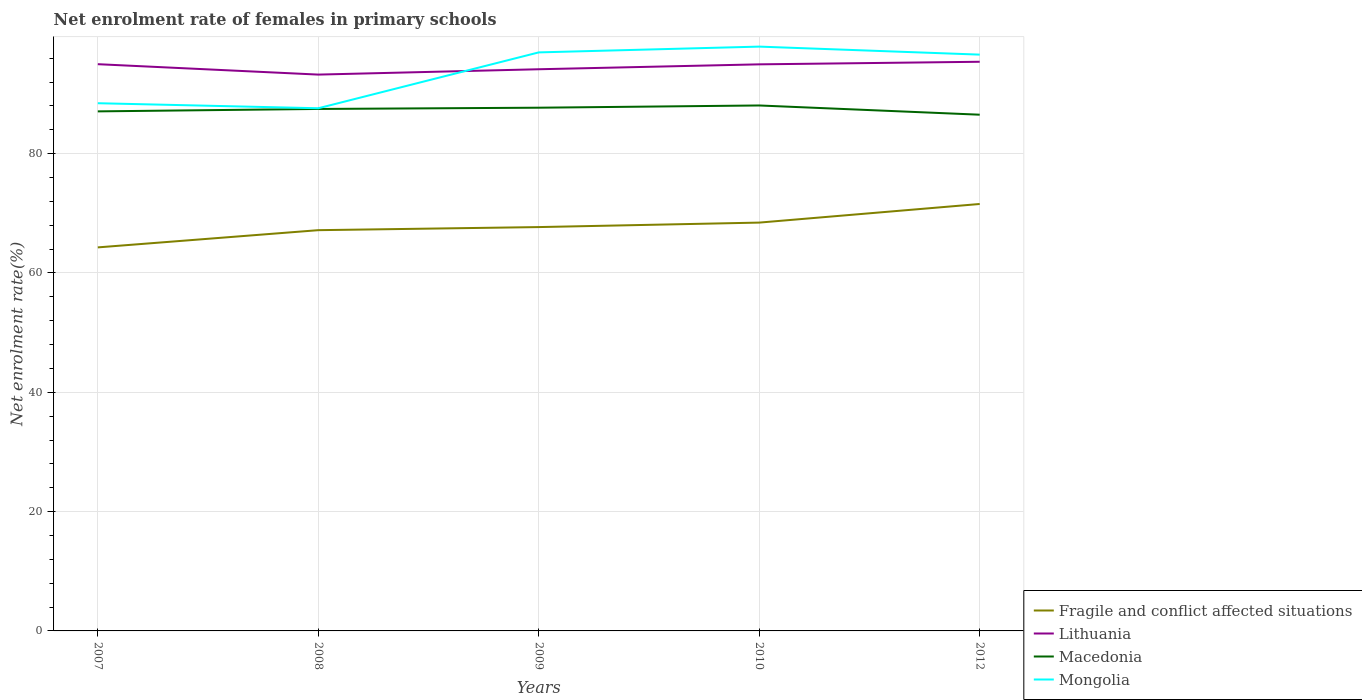How many different coloured lines are there?
Provide a succinct answer. 4. Does the line corresponding to Macedonia intersect with the line corresponding to Fragile and conflict affected situations?
Give a very brief answer. No. Across all years, what is the maximum net enrolment rate of females in primary schools in Fragile and conflict affected situations?
Make the answer very short. 64.29. In which year was the net enrolment rate of females in primary schools in Macedonia maximum?
Your answer should be very brief. 2012. What is the total net enrolment rate of females in primary schools in Macedonia in the graph?
Provide a short and direct response. -0.58. What is the difference between the highest and the second highest net enrolment rate of females in primary schools in Lithuania?
Provide a short and direct response. 2.15. How many lines are there?
Provide a succinct answer. 4. Does the graph contain any zero values?
Your answer should be compact. No. Does the graph contain grids?
Your response must be concise. Yes. How many legend labels are there?
Offer a very short reply. 4. What is the title of the graph?
Provide a short and direct response. Net enrolment rate of females in primary schools. What is the label or title of the X-axis?
Provide a succinct answer. Years. What is the label or title of the Y-axis?
Provide a short and direct response. Net enrolment rate(%). What is the Net enrolment rate(%) of Fragile and conflict affected situations in 2007?
Make the answer very short. 64.29. What is the Net enrolment rate(%) in Lithuania in 2007?
Make the answer very short. 95. What is the Net enrolment rate(%) in Macedonia in 2007?
Provide a succinct answer. 87.09. What is the Net enrolment rate(%) of Mongolia in 2007?
Provide a short and direct response. 88.46. What is the Net enrolment rate(%) in Fragile and conflict affected situations in 2008?
Your response must be concise. 67.17. What is the Net enrolment rate(%) in Lithuania in 2008?
Your answer should be very brief. 93.25. What is the Net enrolment rate(%) in Macedonia in 2008?
Your response must be concise. 87.5. What is the Net enrolment rate(%) of Mongolia in 2008?
Keep it short and to the point. 87.61. What is the Net enrolment rate(%) in Fragile and conflict affected situations in 2009?
Give a very brief answer. 67.69. What is the Net enrolment rate(%) of Lithuania in 2009?
Keep it short and to the point. 94.15. What is the Net enrolment rate(%) in Macedonia in 2009?
Offer a terse response. 87.7. What is the Net enrolment rate(%) in Mongolia in 2009?
Provide a short and direct response. 96.97. What is the Net enrolment rate(%) of Fragile and conflict affected situations in 2010?
Your answer should be compact. 68.44. What is the Net enrolment rate(%) in Lithuania in 2010?
Offer a terse response. 94.97. What is the Net enrolment rate(%) in Macedonia in 2010?
Your response must be concise. 88.08. What is the Net enrolment rate(%) in Mongolia in 2010?
Provide a succinct answer. 97.94. What is the Net enrolment rate(%) of Fragile and conflict affected situations in 2012?
Your response must be concise. 71.57. What is the Net enrolment rate(%) in Lithuania in 2012?
Your answer should be very brief. 95.41. What is the Net enrolment rate(%) of Macedonia in 2012?
Your answer should be very brief. 86.53. What is the Net enrolment rate(%) of Mongolia in 2012?
Keep it short and to the point. 96.6. Across all years, what is the maximum Net enrolment rate(%) in Fragile and conflict affected situations?
Your answer should be compact. 71.57. Across all years, what is the maximum Net enrolment rate(%) of Lithuania?
Provide a succinct answer. 95.41. Across all years, what is the maximum Net enrolment rate(%) of Macedonia?
Provide a succinct answer. 88.08. Across all years, what is the maximum Net enrolment rate(%) of Mongolia?
Your answer should be very brief. 97.94. Across all years, what is the minimum Net enrolment rate(%) of Fragile and conflict affected situations?
Keep it short and to the point. 64.29. Across all years, what is the minimum Net enrolment rate(%) in Lithuania?
Ensure brevity in your answer.  93.25. Across all years, what is the minimum Net enrolment rate(%) in Macedonia?
Make the answer very short. 86.53. Across all years, what is the minimum Net enrolment rate(%) in Mongolia?
Make the answer very short. 87.61. What is the total Net enrolment rate(%) in Fragile and conflict affected situations in the graph?
Keep it short and to the point. 339.17. What is the total Net enrolment rate(%) in Lithuania in the graph?
Ensure brevity in your answer.  472.78. What is the total Net enrolment rate(%) in Macedonia in the graph?
Your response must be concise. 436.89. What is the total Net enrolment rate(%) of Mongolia in the graph?
Offer a terse response. 467.59. What is the difference between the Net enrolment rate(%) of Fragile and conflict affected situations in 2007 and that in 2008?
Give a very brief answer. -2.89. What is the difference between the Net enrolment rate(%) of Lithuania in 2007 and that in 2008?
Offer a very short reply. 1.74. What is the difference between the Net enrolment rate(%) in Macedonia in 2007 and that in 2008?
Ensure brevity in your answer.  -0.41. What is the difference between the Net enrolment rate(%) of Mongolia in 2007 and that in 2008?
Provide a succinct answer. 0.84. What is the difference between the Net enrolment rate(%) of Fragile and conflict affected situations in 2007 and that in 2009?
Provide a short and direct response. -3.41. What is the difference between the Net enrolment rate(%) in Lithuania in 2007 and that in 2009?
Make the answer very short. 0.85. What is the difference between the Net enrolment rate(%) in Macedonia in 2007 and that in 2009?
Give a very brief answer. -0.62. What is the difference between the Net enrolment rate(%) of Mongolia in 2007 and that in 2009?
Offer a very short reply. -8.52. What is the difference between the Net enrolment rate(%) of Fragile and conflict affected situations in 2007 and that in 2010?
Provide a succinct answer. -4.16. What is the difference between the Net enrolment rate(%) in Lithuania in 2007 and that in 2010?
Provide a short and direct response. 0.03. What is the difference between the Net enrolment rate(%) in Macedonia in 2007 and that in 2010?
Give a very brief answer. -0.99. What is the difference between the Net enrolment rate(%) of Mongolia in 2007 and that in 2010?
Your answer should be very brief. -9.49. What is the difference between the Net enrolment rate(%) of Fragile and conflict affected situations in 2007 and that in 2012?
Your answer should be very brief. -7.28. What is the difference between the Net enrolment rate(%) of Lithuania in 2007 and that in 2012?
Your answer should be compact. -0.41. What is the difference between the Net enrolment rate(%) of Macedonia in 2007 and that in 2012?
Keep it short and to the point. 0.56. What is the difference between the Net enrolment rate(%) in Mongolia in 2007 and that in 2012?
Offer a terse response. -8.15. What is the difference between the Net enrolment rate(%) in Fragile and conflict affected situations in 2008 and that in 2009?
Give a very brief answer. -0.52. What is the difference between the Net enrolment rate(%) in Lithuania in 2008 and that in 2009?
Provide a short and direct response. -0.9. What is the difference between the Net enrolment rate(%) of Macedonia in 2008 and that in 2009?
Offer a very short reply. -0.21. What is the difference between the Net enrolment rate(%) in Mongolia in 2008 and that in 2009?
Offer a very short reply. -9.36. What is the difference between the Net enrolment rate(%) of Fragile and conflict affected situations in 2008 and that in 2010?
Offer a very short reply. -1.27. What is the difference between the Net enrolment rate(%) in Lithuania in 2008 and that in 2010?
Provide a short and direct response. -1.72. What is the difference between the Net enrolment rate(%) of Macedonia in 2008 and that in 2010?
Your answer should be very brief. -0.58. What is the difference between the Net enrolment rate(%) of Mongolia in 2008 and that in 2010?
Keep it short and to the point. -10.33. What is the difference between the Net enrolment rate(%) in Fragile and conflict affected situations in 2008 and that in 2012?
Provide a short and direct response. -4.39. What is the difference between the Net enrolment rate(%) in Lithuania in 2008 and that in 2012?
Your answer should be very brief. -2.15. What is the difference between the Net enrolment rate(%) of Macedonia in 2008 and that in 2012?
Provide a short and direct response. 0.97. What is the difference between the Net enrolment rate(%) in Mongolia in 2008 and that in 2012?
Your answer should be compact. -8.99. What is the difference between the Net enrolment rate(%) of Fragile and conflict affected situations in 2009 and that in 2010?
Your answer should be compact. -0.75. What is the difference between the Net enrolment rate(%) in Lithuania in 2009 and that in 2010?
Offer a very short reply. -0.82. What is the difference between the Net enrolment rate(%) of Macedonia in 2009 and that in 2010?
Your answer should be very brief. -0.38. What is the difference between the Net enrolment rate(%) of Mongolia in 2009 and that in 2010?
Ensure brevity in your answer.  -0.97. What is the difference between the Net enrolment rate(%) of Fragile and conflict affected situations in 2009 and that in 2012?
Provide a succinct answer. -3.87. What is the difference between the Net enrolment rate(%) in Lithuania in 2009 and that in 2012?
Your response must be concise. -1.26. What is the difference between the Net enrolment rate(%) in Macedonia in 2009 and that in 2012?
Provide a succinct answer. 1.17. What is the difference between the Net enrolment rate(%) in Mongolia in 2009 and that in 2012?
Keep it short and to the point. 0.37. What is the difference between the Net enrolment rate(%) in Fragile and conflict affected situations in 2010 and that in 2012?
Make the answer very short. -3.12. What is the difference between the Net enrolment rate(%) of Lithuania in 2010 and that in 2012?
Give a very brief answer. -0.43. What is the difference between the Net enrolment rate(%) in Macedonia in 2010 and that in 2012?
Your response must be concise. 1.55. What is the difference between the Net enrolment rate(%) of Mongolia in 2010 and that in 2012?
Provide a short and direct response. 1.34. What is the difference between the Net enrolment rate(%) in Fragile and conflict affected situations in 2007 and the Net enrolment rate(%) in Lithuania in 2008?
Make the answer very short. -28.97. What is the difference between the Net enrolment rate(%) of Fragile and conflict affected situations in 2007 and the Net enrolment rate(%) of Macedonia in 2008?
Keep it short and to the point. -23.21. What is the difference between the Net enrolment rate(%) of Fragile and conflict affected situations in 2007 and the Net enrolment rate(%) of Mongolia in 2008?
Offer a terse response. -23.32. What is the difference between the Net enrolment rate(%) of Lithuania in 2007 and the Net enrolment rate(%) of Macedonia in 2008?
Your response must be concise. 7.5. What is the difference between the Net enrolment rate(%) of Lithuania in 2007 and the Net enrolment rate(%) of Mongolia in 2008?
Give a very brief answer. 7.39. What is the difference between the Net enrolment rate(%) in Macedonia in 2007 and the Net enrolment rate(%) in Mongolia in 2008?
Provide a short and direct response. -0.52. What is the difference between the Net enrolment rate(%) in Fragile and conflict affected situations in 2007 and the Net enrolment rate(%) in Lithuania in 2009?
Make the answer very short. -29.86. What is the difference between the Net enrolment rate(%) in Fragile and conflict affected situations in 2007 and the Net enrolment rate(%) in Macedonia in 2009?
Offer a very short reply. -23.41. What is the difference between the Net enrolment rate(%) of Fragile and conflict affected situations in 2007 and the Net enrolment rate(%) of Mongolia in 2009?
Provide a short and direct response. -32.69. What is the difference between the Net enrolment rate(%) in Lithuania in 2007 and the Net enrolment rate(%) in Macedonia in 2009?
Provide a short and direct response. 7.3. What is the difference between the Net enrolment rate(%) in Lithuania in 2007 and the Net enrolment rate(%) in Mongolia in 2009?
Your answer should be compact. -1.98. What is the difference between the Net enrolment rate(%) of Macedonia in 2007 and the Net enrolment rate(%) of Mongolia in 2009?
Your response must be concise. -9.89. What is the difference between the Net enrolment rate(%) of Fragile and conflict affected situations in 2007 and the Net enrolment rate(%) of Lithuania in 2010?
Your response must be concise. -30.68. What is the difference between the Net enrolment rate(%) of Fragile and conflict affected situations in 2007 and the Net enrolment rate(%) of Macedonia in 2010?
Offer a terse response. -23.79. What is the difference between the Net enrolment rate(%) of Fragile and conflict affected situations in 2007 and the Net enrolment rate(%) of Mongolia in 2010?
Offer a very short reply. -33.66. What is the difference between the Net enrolment rate(%) in Lithuania in 2007 and the Net enrolment rate(%) in Macedonia in 2010?
Provide a short and direct response. 6.92. What is the difference between the Net enrolment rate(%) in Lithuania in 2007 and the Net enrolment rate(%) in Mongolia in 2010?
Your answer should be very brief. -2.94. What is the difference between the Net enrolment rate(%) in Macedonia in 2007 and the Net enrolment rate(%) in Mongolia in 2010?
Offer a terse response. -10.86. What is the difference between the Net enrolment rate(%) in Fragile and conflict affected situations in 2007 and the Net enrolment rate(%) in Lithuania in 2012?
Offer a terse response. -31.12. What is the difference between the Net enrolment rate(%) in Fragile and conflict affected situations in 2007 and the Net enrolment rate(%) in Macedonia in 2012?
Provide a short and direct response. -22.24. What is the difference between the Net enrolment rate(%) of Fragile and conflict affected situations in 2007 and the Net enrolment rate(%) of Mongolia in 2012?
Offer a terse response. -32.31. What is the difference between the Net enrolment rate(%) of Lithuania in 2007 and the Net enrolment rate(%) of Macedonia in 2012?
Your answer should be compact. 8.47. What is the difference between the Net enrolment rate(%) of Lithuania in 2007 and the Net enrolment rate(%) of Mongolia in 2012?
Keep it short and to the point. -1.6. What is the difference between the Net enrolment rate(%) in Macedonia in 2007 and the Net enrolment rate(%) in Mongolia in 2012?
Provide a succinct answer. -9.51. What is the difference between the Net enrolment rate(%) in Fragile and conflict affected situations in 2008 and the Net enrolment rate(%) in Lithuania in 2009?
Ensure brevity in your answer.  -26.98. What is the difference between the Net enrolment rate(%) in Fragile and conflict affected situations in 2008 and the Net enrolment rate(%) in Macedonia in 2009?
Make the answer very short. -20.53. What is the difference between the Net enrolment rate(%) of Fragile and conflict affected situations in 2008 and the Net enrolment rate(%) of Mongolia in 2009?
Make the answer very short. -29.8. What is the difference between the Net enrolment rate(%) in Lithuania in 2008 and the Net enrolment rate(%) in Macedonia in 2009?
Provide a short and direct response. 5.55. What is the difference between the Net enrolment rate(%) in Lithuania in 2008 and the Net enrolment rate(%) in Mongolia in 2009?
Keep it short and to the point. -3.72. What is the difference between the Net enrolment rate(%) in Macedonia in 2008 and the Net enrolment rate(%) in Mongolia in 2009?
Offer a terse response. -9.48. What is the difference between the Net enrolment rate(%) of Fragile and conflict affected situations in 2008 and the Net enrolment rate(%) of Lithuania in 2010?
Your answer should be compact. -27.8. What is the difference between the Net enrolment rate(%) of Fragile and conflict affected situations in 2008 and the Net enrolment rate(%) of Macedonia in 2010?
Give a very brief answer. -20.9. What is the difference between the Net enrolment rate(%) in Fragile and conflict affected situations in 2008 and the Net enrolment rate(%) in Mongolia in 2010?
Make the answer very short. -30.77. What is the difference between the Net enrolment rate(%) of Lithuania in 2008 and the Net enrolment rate(%) of Macedonia in 2010?
Ensure brevity in your answer.  5.18. What is the difference between the Net enrolment rate(%) in Lithuania in 2008 and the Net enrolment rate(%) in Mongolia in 2010?
Offer a very short reply. -4.69. What is the difference between the Net enrolment rate(%) of Macedonia in 2008 and the Net enrolment rate(%) of Mongolia in 2010?
Offer a very short reply. -10.45. What is the difference between the Net enrolment rate(%) in Fragile and conflict affected situations in 2008 and the Net enrolment rate(%) in Lithuania in 2012?
Your response must be concise. -28.23. What is the difference between the Net enrolment rate(%) in Fragile and conflict affected situations in 2008 and the Net enrolment rate(%) in Macedonia in 2012?
Make the answer very short. -19.36. What is the difference between the Net enrolment rate(%) in Fragile and conflict affected situations in 2008 and the Net enrolment rate(%) in Mongolia in 2012?
Make the answer very short. -29.43. What is the difference between the Net enrolment rate(%) of Lithuania in 2008 and the Net enrolment rate(%) of Macedonia in 2012?
Give a very brief answer. 6.72. What is the difference between the Net enrolment rate(%) in Lithuania in 2008 and the Net enrolment rate(%) in Mongolia in 2012?
Provide a short and direct response. -3.35. What is the difference between the Net enrolment rate(%) of Macedonia in 2008 and the Net enrolment rate(%) of Mongolia in 2012?
Offer a terse response. -9.11. What is the difference between the Net enrolment rate(%) of Fragile and conflict affected situations in 2009 and the Net enrolment rate(%) of Lithuania in 2010?
Provide a short and direct response. -27.28. What is the difference between the Net enrolment rate(%) of Fragile and conflict affected situations in 2009 and the Net enrolment rate(%) of Macedonia in 2010?
Make the answer very short. -20.38. What is the difference between the Net enrolment rate(%) of Fragile and conflict affected situations in 2009 and the Net enrolment rate(%) of Mongolia in 2010?
Make the answer very short. -30.25. What is the difference between the Net enrolment rate(%) of Lithuania in 2009 and the Net enrolment rate(%) of Macedonia in 2010?
Provide a succinct answer. 6.07. What is the difference between the Net enrolment rate(%) in Lithuania in 2009 and the Net enrolment rate(%) in Mongolia in 2010?
Give a very brief answer. -3.79. What is the difference between the Net enrolment rate(%) of Macedonia in 2009 and the Net enrolment rate(%) of Mongolia in 2010?
Provide a succinct answer. -10.24. What is the difference between the Net enrolment rate(%) of Fragile and conflict affected situations in 2009 and the Net enrolment rate(%) of Lithuania in 2012?
Give a very brief answer. -27.71. What is the difference between the Net enrolment rate(%) in Fragile and conflict affected situations in 2009 and the Net enrolment rate(%) in Macedonia in 2012?
Provide a short and direct response. -18.84. What is the difference between the Net enrolment rate(%) of Fragile and conflict affected situations in 2009 and the Net enrolment rate(%) of Mongolia in 2012?
Your answer should be very brief. -28.91. What is the difference between the Net enrolment rate(%) of Lithuania in 2009 and the Net enrolment rate(%) of Macedonia in 2012?
Your response must be concise. 7.62. What is the difference between the Net enrolment rate(%) of Lithuania in 2009 and the Net enrolment rate(%) of Mongolia in 2012?
Your answer should be very brief. -2.45. What is the difference between the Net enrolment rate(%) of Macedonia in 2009 and the Net enrolment rate(%) of Mongolia in 2012?
Your answer should be compact. -8.9. What is the difference between the Net enrolment rate(%) of Fragile and conflict affected situations in 2010 and the Net enrolment rate(%) of Lithuania in 2012?
Your response must be concise. -26.96. What is the difference between the Net enrolment rate(%) of Fragile and conflict affected situations in 2010 and the Net enrolment rate(%) of Macedonia in 2012?
Keep it short and to the point. -18.09. What is the difference between the Net enrolment rate(%) of Fragile and conflict affected situations in 2010 and the Net enrolment rate(%) of Mongolia in 2012?
Provide a succinct answer. -28.16. What is the difference between the Net enrolment rate(%) of Lithuania in 2010 and the Net enrolment rate(%) of Macedonia in 2012?
Provide a succinct answer. 8.44. What is the difference between the Net enrolment rate(%) of Lithuania in 2010 and the Net enrolment rate(%) of Mongolia in 2012?
Your answer should be compact. -1.63. What is the difference between the Net enrolment rate(%) of Macedonia in 2010 and the Net enrolment rate(%) of Mongolia in 2012?
Make the answer very short. -8.52. What is the average Net enrolment rate(%) of Fragile and conflict affected situations per year?
Provide a succinct answer. 67.83. What is the average Net enrolment rate(%) in Lithuania per year?
Provide a short and direct response. 94.56. What is the average Net enrolment rate(%) of Macedonia per year?
Provide a short and direct response. 87.38. What is the average Net enrolment rate(%) in Mongolia per year?
Provide a short and direct response. 93.52. In the year 2007, what is the difference between the Net enrolment rate(%) of Fragile and conflict affected situations and Net enrolment rate(%) of Lithuania?
Make the answer very short. -30.71. In the year 2007, what is the difference between the Net enrolment rate(%) in Fragile and conflict affected situations and Net enrolment rate(%) in Macedonia?
Your answer should be very brief. -22.8. In the year 2007, what is the difference between the Net enrolment rate(%) in Fragile and conflict affected situations and Net enrolment rate(%) in Mongolia?
Give a very brief answer. -24.17. In the year 2007, what is the difference between the Net enrolment rate(%) of Lithuania and Net enrolment rate(%) of Macedonia?
Give a very brief answer. 7.91. In the year 2007, what is the difference between the Net enrolment rate(%) of Lithuania and Net enrolment rate(%) of Mongolia?
Provide a short and direct response. 6.54. In the year 2007, what is the difference between the Net enrolment rate(%) of Macedonia and Net enrolment rate(%) of Mongolia?
Your answer should be very brief. -1.37. In the year 2008, what is the difference between the Net enrolment rate(%) in Fragile and conflict affected situations and Net enrolment rate(%) in Lithuania?
Your response must be concise. -26.08. In the year 2008, what is the difference between the Net enrolment rate(%) in Fragile and conflict affected situations and Net enrolment rate(%) in Macedonia?
Your answer should be compact. -20.32. In the year 2008, what is the difference between the Net enrolment rate(%) of Fragile and conflict affected situations and Net enrolment rate(%) of Mongolia?
Your response must be concise. -20.44. In the year 2008, what is the difference between the Net enrolment rate(%) of Lithuania and Net enrolment rate(%) of Macedonia?
Provide a short and direct response. 5.76. In the year 2008, what is the difference between the Net enrolment rate(%) of Lithuania and Net enrolment rate(%) of Mongolia?
Keep it short and to the point. 5.64. In the year 2008, what is the difference between the Net enrolment rate(%) in Macedonia and Net enrolment rate(%) in Mongolia?
Your answer should be compact. -0.12. In the year 2009, what is the difference between the Net enrolment rate(%) of Fragile and conflict affected situations and Net enrolment rate(%) of Lithuania?
Your answer should be very brief. -26.46. In the year 2009, what is the difference between the Net enrolment rate(%) of Fragile and conflict affected situations and Net enrolment rate(%) of Macedonia?
Offer a terse response. -20.01. In the year 2009, what is the difference between the Net enrolment rate(%) of Fragile and conflict affected situations and Net enrolment rate(%) of Mongolia?
Provide a short and direct response. -29.28. In the year 2009, what is the difference between the Net enrolment rate(%) of Lithuania and Net enrolment rate(%) of Macedonia?
Your answer should be very brief. 6.45. In the year 2009, what is the difference between the Net enrolment rate(%) of Lithuania and Net enrolment rate(%) of Mongolia?
Your answer should be very brief. -2.82. In the year 2009, what is the difference between the Net enrolment rate(%) in Macedonia and Net enrolment rate(%) in Mongolia?
Ensure brevity in your answer.  -9.27. In the year 2010, what is the difference between the Net enrolment rate(%) of Fragile and conflict affected situations and Net enrolment rate(%) of Lithuania?
Provide a succinct answer. -26.53. In the year 2010, what is the difference between the Net enrolment rate(%) in Fragile and conflict affected situations and Net enrolment rate(%) in Macedonia?
Ensure brevity in your answer.  -19.63. In the year 2010, what is the difference between the Net enrolment rate(%) of Fragile and conflict affected situations and Net enrolment rate(%) of Mongolia?
Provide a short and direct response. -29.5. In the year 2010, what is the difference between the Net enrolment rate(%) of Lithuania and Net enrolment rate(%) of Macedonia?
Provide a short and direct response. 6.89. In the year 2010, what is the difference between the Net enrolment rate(%) of Lithuania and Net enrolment rate(%) of Mongolia?
Your response must be concise. -2.97. In the year 2010, what is the difference between the Net enrolment rate(%) of Macedonia and Net enrolment rate(%) of Mongolia?
Keep it short and to the point. -9.87. In the year 2012, what is the difference between the Net enrolment rate(%) of Fragile and conflict affected situations and Net enrolment rate(%) of Lithuania?
Your response must be concise. -23.84. In the year 2012, what is the difference between the Net enrolment rate(%) in Fragile and conflict affected situations and Net enrolment rate(%) in Macedonia?
Ensure brevity in your answer.  -14.96. In the year 2012, what is the difference between the Net enrolment rate(%) of Fragile and conflict affected situations and Net enrolment rate(%) of Mongolia?
Provide a short and direct response. -25.04. In the year 2012, what is the difference between the Net enrolment rate(%) of Lithuania and Net enrolment rate(%) of Macedonia?
Keep it short and to the point. 8.88. In the year 2012, what is the difference between the Net enrolment rate(%) of Lithuania and Net enrolment rate(%) of Mongolia?
Give a very brief answer. -1.2. In the year 2012, what is the difference between the Net enrolment rate(%) in Macedonia and Net enrolment rate(%) in Mongolia?
Give a very brief answer. -10.07. What is the ratio of the Net enrolment rate(%) of Lithuania in 2007 to that in 2008?
Offer a very short reply. 1.02. What is the ratio of the Net enrolment rate(%) of Mongolia in 2007 to that in 2008?
Keep it short and to the point. 1.01. What is the ratio of the Net enrolment rate(%) of Fragile and conflict affected situations in 2007 to that in 2009?
Provide a succinct answer. 0.95. What is the ratio of the Net enrolment rate(%) in Lithuania in 2007 to that in 2009?
Provide a succinct answer. 1.01. What is the ratio of the Net enrolment rate(%) of Mongolia in 2007 to that in 2009?
Offer a terse response. 0.91. What is the ratio of the Net enrolment rate(%) of Fragile and conflict affected situations in 2007 to that in 2010?
Your response must be concise. 0.94. What is the ratio of the Net enrolment rate(%) in Lithuania in 2007 to that in 2010?
Keep it short and to the point. 1. What is the ratio of the Net enrolment rate(%) of Mongolia in 2007 to that in 2010?
Offer a very short reply. 0.9. What is the ratio of the Net enrolment rate(%) of Fragile and conflict affected situations in 2007 to that in 2012?
Give a very brief answer. 0.9. What is the ratio of the Net enrolment rate(%) of Macedonia in 2007 to that in 2012?
Your answer should be very brief. 1.01. What is the ratio of the Net enrolment rate(%) of Mongolia in 2007 to that in 2012?
Your response must be concise. 0.92. What is the ratio of the Net enrolment rate(%) of Lithuania in 2008 to that in 2009?
Provide a succinct answer. 0.99. What is the ratio of the Net enrolment rate(%) of Macedonia in 2008 to that in 2009?
Give a very brief answer. 1. What is the ratio of the Net enrolment rate(%) in Mongolia in 2008 to that in 2009?
Your answer should be compact. 0.9. What is the ratio of the Net enrolment rate(%) in Fragile and conflict affected situations in 2008 to that in 2010?
Provide a succinct answer. 0.98. What is the ratio of the Net enrolment rate(%) of Lithuania in 2008 to that in 2010?
Keep it short and to the point. 0.98. What is the ratio of the Net enrolment rate(%) in Mongolia in 2008 to that in 2010?
Your answer should be compact. 0.89. What is the ratio of the Net enrolment rate(%) in Fragile and conflict affected situations in 2008 to that in 2012?
Ensure brevity in your answer.  0.94. What is the ratio of the Net enrolment rate(%) of Lithuania in 2008 to that in 2012?
Provide a succinct answer. 0.98. What is the ratio of the Net enrolment rate(%) in Macedonia in 2008 to that in 2012?
Provide a succinct answer. 1.01. What is the ratio of the Net enrolment rate(%) of Mongolia in 2008 to that in 2012?
Provide a short and direct response. 0.91. What is the ratio of the Net enrolment rate(%) in Fragile and conflict affected situations in 2009 to that in 2010?
Offer a very short reply. 0.99. What is the ratio of the Net enrolment rate(%) in Lithuania in 2009 to that in 2010?
Give a very brief answer. 0.99. What is the ratio of the Net enrolment rate(%) of Macedonia in 2009 to that in 2010?
Keep it short and to the point. 1. What is the ratio of the Net enrolment rate(%) of Mongolia in 2009 to that in 2010?
Your answer should be very brief. 0.99. What is the ratio of the Net enrolment rate(%) in Fragile and conflict affected situations in 2009 to that in 2012?
Your answer should be compact. 0.95. What is the ratio of the Net enrolment rate(%) in Lithuania in 2009 to that in 2012?
Provide a succinct answer. 0.99. What is the ratio of the Net enrolment rate(%) of Macedonia in 2009 to that in 2012?
Give a very brief answer. 1.01. What is the ratio of the Net enrolment rate(%) of Mongolia in 2009 to that in 2012?
Offer a very short reply. 1. What is the ratio of the Net enrolment rate(%) of Fragile and conflict affected situations in 2010 to that in 2012?
Keep it short and to the point. 0.96. What is the ratio of the Net enrolment rate(%) in Lithuania in 2010 to that in 2012?
Ensure brevity in your answer.  1. What is the ratio of the Net enrolment rate(%) of Macedonia in 2010 to that in 2012?
Provide a succinct answer. 1.02. What is the ratio of the Net enrolment rate(%) of Mongolia in 2010 to that in 2012?
Offer a terse response. 1.01. What is the difference between the highest and the second highest Net enrolment rate(%) of Fragile and conflict affected situations?
Provide a succinct answer. 3.12. What is the difference between the highest and the second highest Net enrolment rate(%) of Lithuania?
Make the answer very short. 0.41. What is the difference between the highest and the second highest Net enrolment rate(%) of Macedonia?
Provide a succinct answer. 0.38. What is the difference between the highest and the second highest Net enrolment rate(%) in Mongolia?
Offer a terse response. 0.97. What is the difference between the highest and the lowest Net enrolment rate(%) in Fragile and conflict affected situations?
Provide a short and direct response. 7.28. What is the difference between the highest and the lowest Net enrolment rate(%) in Lithuania?
Keep it short and to the point. 2.15. What is the difference between the highest and the lowest Net enrolment rate(%) in Macedonia?
Make the answer very short. 1.55. What is the difference between the highest and the lowest Net enrolment rate(%) of Mongolia?
Offer a very short reply. 10.33. 